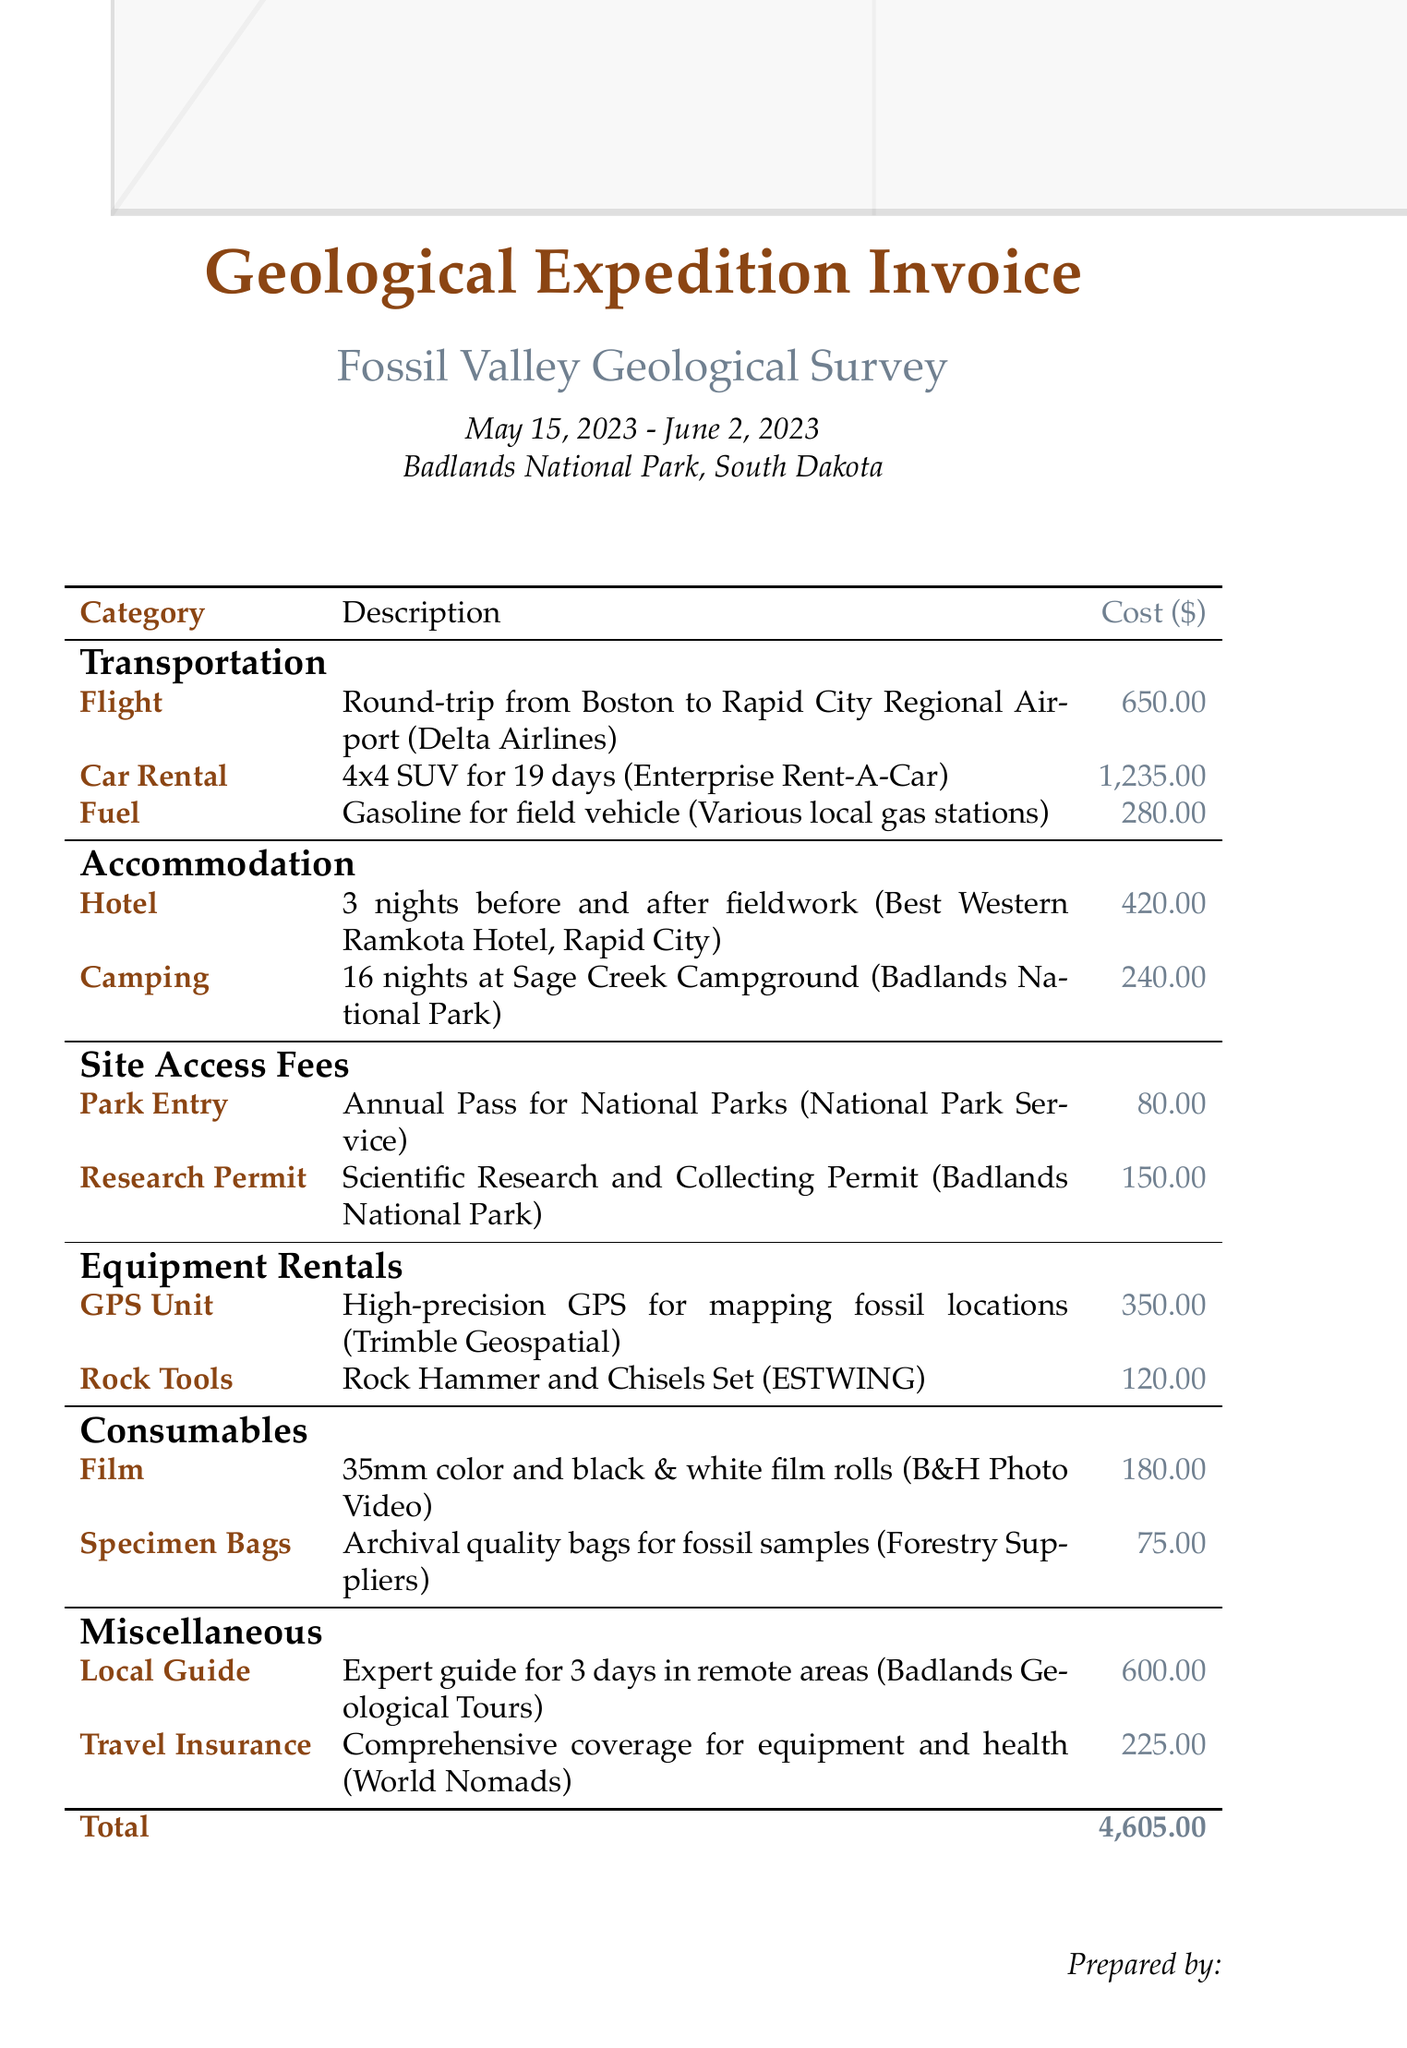What is the name of the expedition? The name of the expedition is stated in the document under expedition details.
Answer: Fossil Valley Geological Survey What are the accommodation costs? The costs for accommodation are detailed in a specific section of the document, showing the total for hotel and camping.
Answer: 660.00 How many days was the car rented? The duration of the car rental is mentioned in the transportation section of the document.
Answer: 19 days What is the total cost of site access fees? The total for site access fees is derived from the sum of park entry and research permit costs.
Answer: 230.00 Who provided the fuel for the expedition? The provider of fuel is detailed in the transportation section.
Answer: Various local gas stations What type of insurance is included in the expenses? The type of insurance is specified in the miscellaneous section, indicating its coverage nature.
Answer: Travel Insurance How many nights were spent camping? The number of nights spent camping is detailed in the accommodation section of the document.
Answer: 16 nights What is the total cost of equipment rentals? The total cost of equipment rentals can be calculated from the costs listed for each equipment rental.
Answer: 470.00 How many different transportation methods are listed? The document outlines how many separate transportation methods were utilized for the expedition.
Answer: 3 